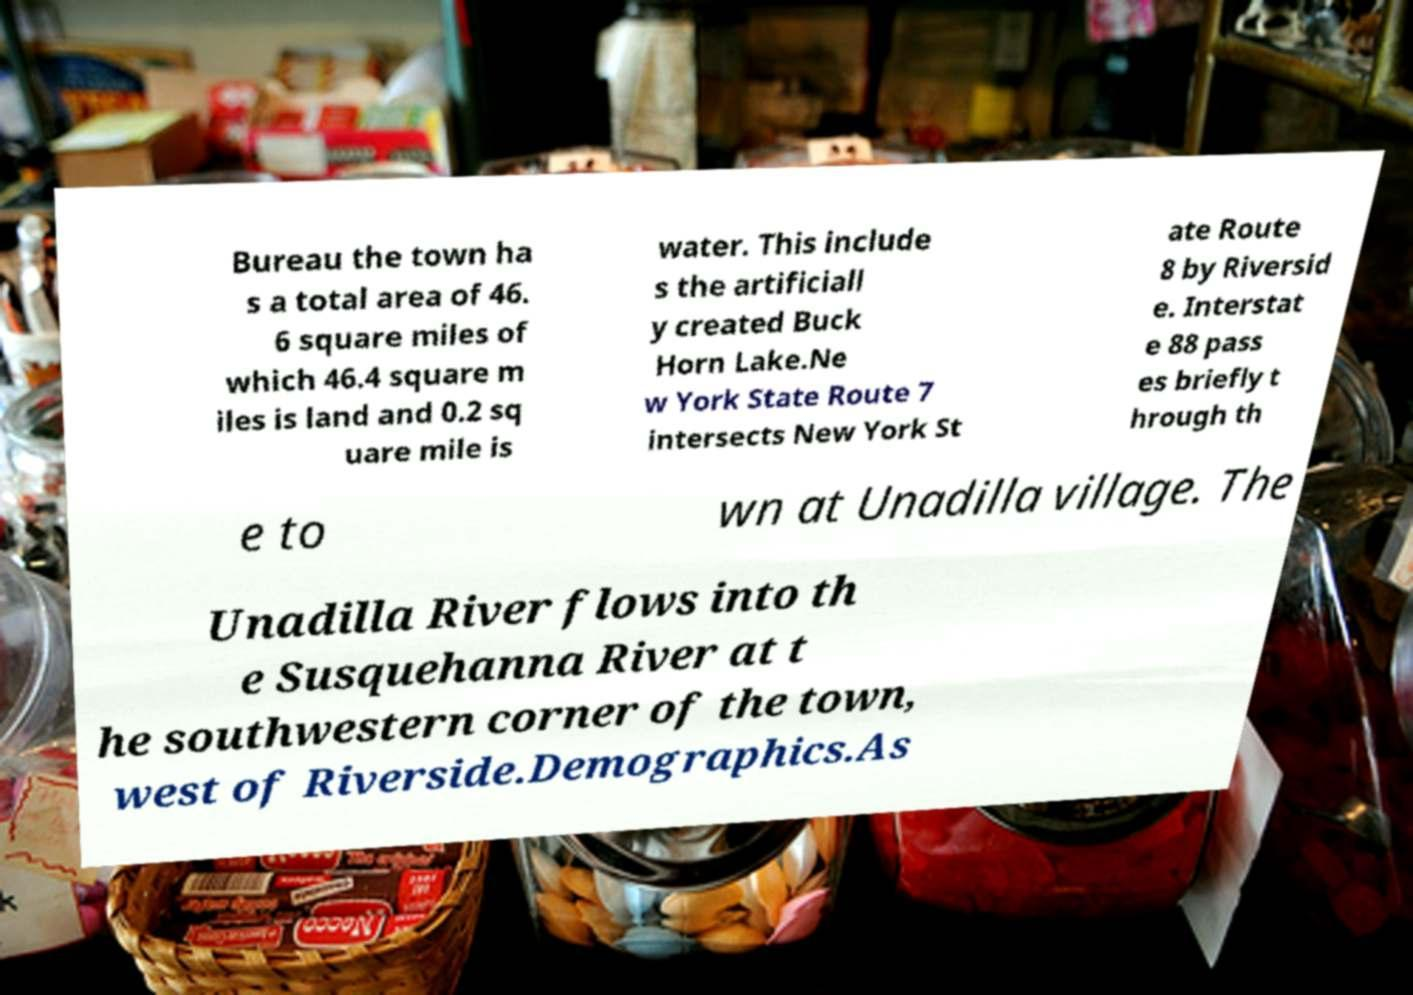What messages or text are displayed in this image? I need them in a readable, typed format. Bureau the town ha s a total area of 46. 6 square miles of which 46.4 square m iles is land and 0.2 sq uare mile is water. This include s the artificiall y created Buck Horn Lake.Ne w York State Route 7 intersects New York St ate Route 8 by Riversid e. Interstat e 88 pass es briefly t hrough th e to wn at Unadilla village. The Unadilla River flows into th e Susquehanna River at t he southwestern corner of the town, west of Riverside.Demographics.As 